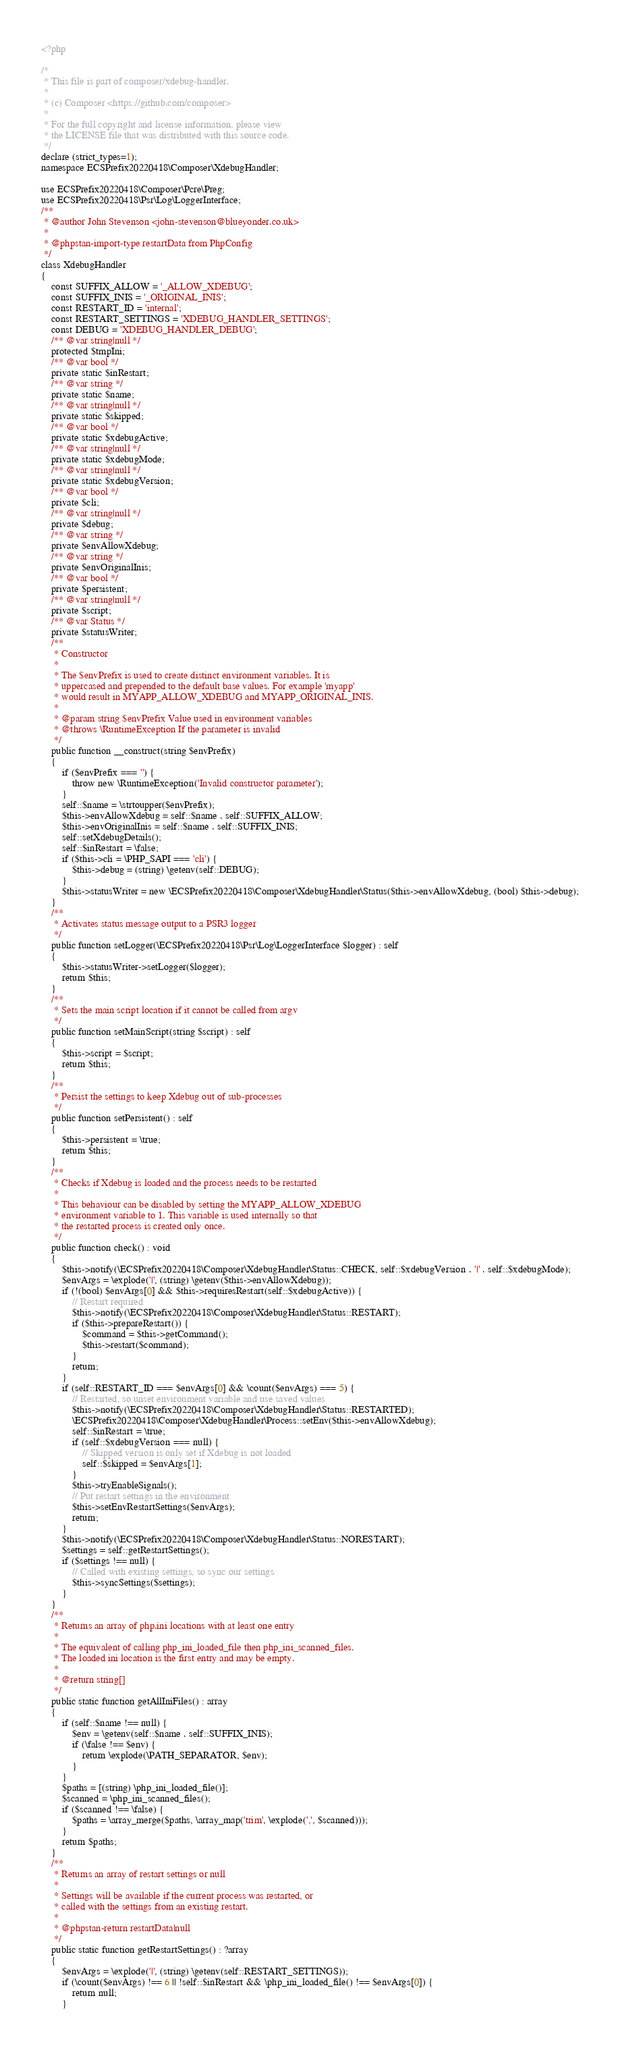Convert code to text. <code><loc_0><loc_0><loc_500><loc_500><_PHP_><?php

/*
 * This file is part of composer/xdebug-handler.
 *
 * (c) Composer <https://github.com/composer>
 *
 * For the full copyright and license information, please view
 * the LICENSE file that was distributed with this source code.
 */
declare (strict_types=1);
namespace ECSPrefix20220418\Composer\XdebugHandler;

use ECSPrefix20220418\Composer\Pcre\Preg;
use ECSPrefix20220418\Psr\Log\LoggerInterface;
/**
 * @author John Stevenson <john-stevenson@blueyonder.co.uk>
 *
 * @phpstan-import-type restartData from PhpConfig
 */
class XdebugHandler
{
    const SUFFIX_ALLOW = '_ALLOW_XDEBUG';
    const SUFFIX_INIS = '_ORIGINAL_INIS';
    const RESTART_ID = 'internal';
    const RESTART_SETTINGS = 'XDEBUG_HANDLER_SETTINGS';
    const DEBUG = 'XDEBUG_HANDLER_DEBUG';
    /** @var string|null */
    protected $tmpIni;
    /** @var bool */
    private static $inRestart;
    /** @var string */
    private static $name;
    /** @var string|null */
    private static $skipped;
    /** @var bool */
    private static $xdebugActive;
    /** @var string|null */
    private static $xdebugMode;
    /** @var string|null */
    private static $xdebugVersion;
    /** @var bool */
    private $cli;
    /** @var string|null */
    private $debug;
    /** @var string */
    private $envAllowXdebug;
    /** @var string */
    private $envOriginalInis;
    /** @var bool */
    private $persistent;
    /** @var string|null */
    private $script;
    /** @var Status */
    private $statusWriter;
    /**
     * Constructor
     *
     * The $envPrefix is used to create distinct environment variables. It is
     * uppercased and prepended to the default base values. For example 'myapp'
     * would result in MYAPP_ALLOW_XDEBUG and MYAPP_ORIGINAL_INIS.
     *
     * @param string $envPrefix Value used in environment variables
     * @throws \RuntimeException If the parameter is invalid
     */
    public function __construct(string $envPrefix)
    {
        if ($envPrefix === '') {
            throw new \RuntimeException('Invalid constructor parameter');
        }
        self::$name = \strtoupper($envPrefix);
        $this->envAllowXdebug = self::$name . self::SUFFIX_ALLOW;
        $this->envOriginalInis = self::$name . self::SUFFIX_INIS;
        self::setXdebugDetails();
        self::$inRestart = \false;
        if ($this->cli = \PHP_SAPI === 'cli') {
            $this->debug = (string) \getenv(self::DEBUG);
        }
        $this->statusWriter = new \ECSPrefix20220418\Composer\XdebugHandler\Status($this->envAllowXdebug, (bool) $this->debug);
    }
    /**
     * Activates status message output to a PSR3 logger
     */
    public function setLogger(\ECSPrefix20220418\Psr\Log\LoggerInterface $logger) : self
    {
        $this->statusWriter->setLogger($logger);
        return $this;
    }
    /**
     * Sets the main script location if it cannot be called from argv
     */
    public function setMainScript(string $script) : self
    {
        $this->script = $script;
        return $this;
    }
    /**
     * Persist the settings to keep Xdebug out of sub-processes
     */
    public function setPersistent() : self
    {
        $this->persistent = \true;
        return $this;
    }
    /**
     * Checks if Xdebug is loaded and the process needs to be restarted
     *
     * This behaviour can be disabled by setting the MYAPP_ALLOW_XDEBUG
     * environment variable to 1. This variable is used internally so that
     * the restarted process is created only once.
     */
    public function check() : void
    {
        $this->notify(\ECSPrefix20220418\Composer\XdebugHandler\Status::CHECK, self::$xdebugVersion . '|' . self::$xdebugMode);
        $envArgs = \explode('|', (string) \getenv($this->envAllowXdebug));
        if (!(bool) $envArgs[0] && $this->requiresRestart(self::$xdebugActive)) {
            // Restart required
            $this->notify(\ECSPrefix20220418\Composer\XdebugHandler\Status::RESTART);
            if ($this->prepareRestart()) {
                $command = $this->getCommand();
                $this->restart($command);
            }
            return;
        }
        if (self::RESTART_ID === $envArgs[0] && \count($envArgs) === 5) {
            // Restarted, so unset environment variable and use saved values
            $this->notify(\ECSPrefix20220418\Composer\XdebugHandler\Status::RESTARTED);
            \ECSPrefix20220418\Composer\XdebugHandler\Process::setEnv($this->envAllowXdebug);
            self::$inRestart = \true;
            if (self::$xdebugVersion === null) {
                // Skipped version is only set if Xdebug is not loaded
                self::$skipped = $envArgs[1];
            }
            $this->tryEnableSignals();
            // Put restart settings in the environment
            $this->setEnvRestartSettings($envArgs);
            return;
        }
        $this->notify(\ECSPrefix20220418\Composer\XdebugHandler\Status::NORESTART);
        $settings = self::getRestartSettings();
        if ($settings !== null) {
            // Called with existing settings, so sync our settings
            $this->syncSettings($settings);
        }
    }
    /**
     * Returns an array of php.ini locations with at least one entry
     *
     * The equivalent of calling php_ini_loaded_file then php_ini_scanned_files.
     * The loaded ini location is the first entry and may be empty.
     *
     * @return string[]
     */
    public static function getAllIniFiles() : array
    {
        if (self::$name !== null) {
            $env = \getenv(self::$name . self::SUFFIX_INIS);
            if (\false !== $env) {
                return \explode(\PATH_SEPARATOR, $env);
            }
        }
        $paths = [(string) \php_ini_loaded_file()];
        $scanned = \php_ini_scanned_files();
        if ($scanned !== \false) {
            $paths = \array_merge($paths, \array_map('trim', \explode(',', $scanned)));
        }
        return $paths;
    }
    /**
     * Returns an array of restart settings or null
     *
     * Settings will be available if the current process was restarted, or
     * called with the settings from an existing restart.
     *
     * @phpstan-return restartData|null
     */
    public static function getRestartSettings() : ?array
    {
        $envArgs = \explode('|', (string) \getenv(self::RESTART_SETTINGS));
        if (\count($envArgs) !== 6 || !self::$inRestart && \php_ini_loaded_file() !== $envArgs[0]) {
            return null;
        }</code> 